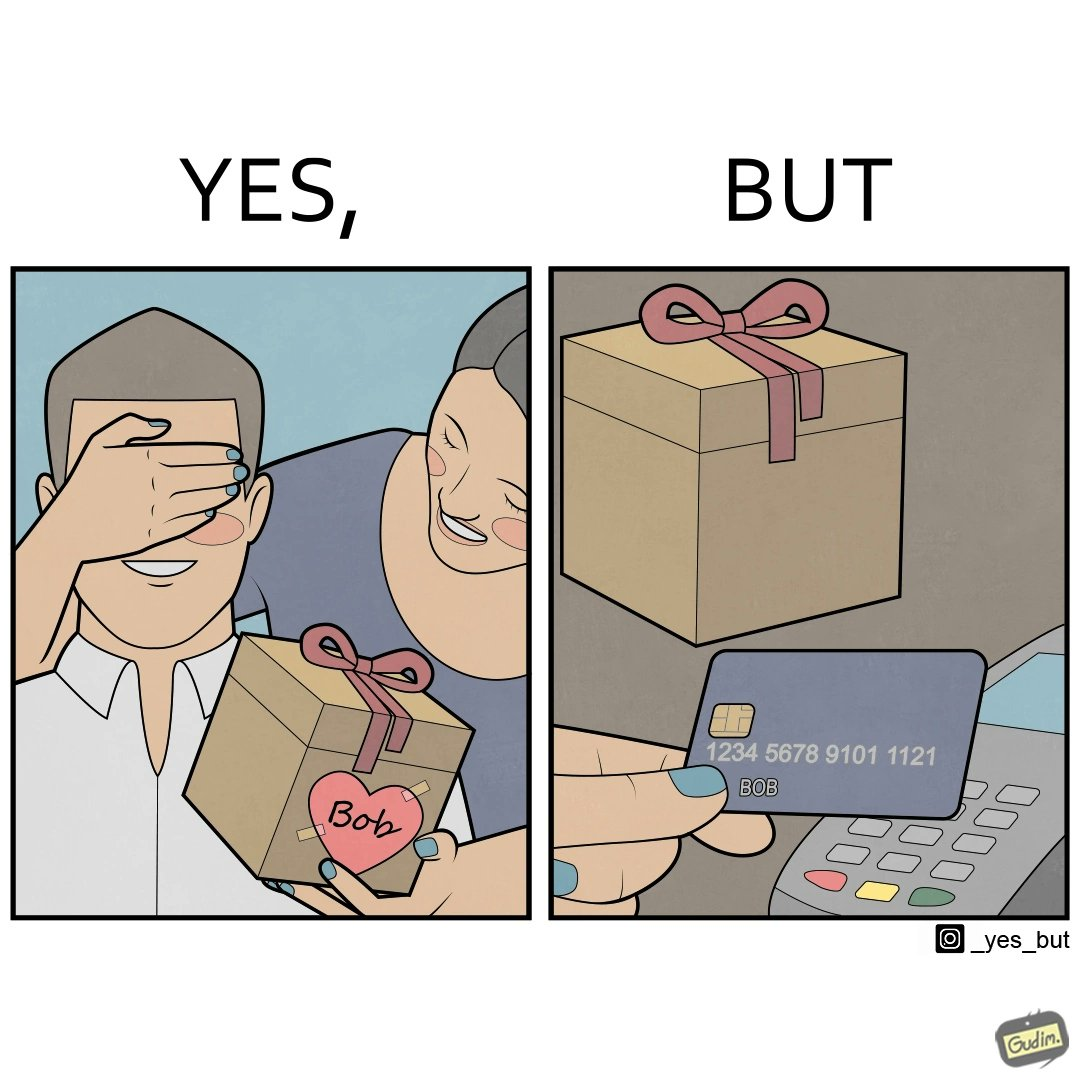Would you classify this image as satirical? Yes, this image is satirical. 